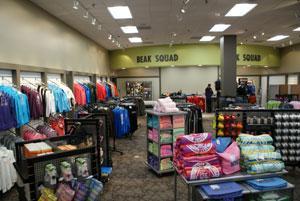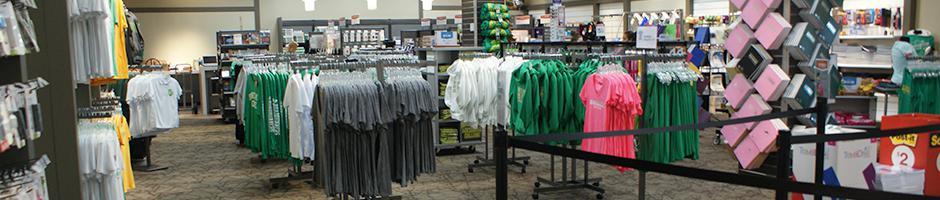The first image is the image on the left, the second image is the image on the right. For the images shown, is this caption "Several of the books on the shelves have yellow stickers." true? Answer yes or no. No. The first image is the image on the left, the second image is the image on the right. Examine the images to the left and right. Is the description "In at least one image, books are stacked on their sides on shelves, some with yellow rectangles on their spines." accurate? Answer yes or no. No. 